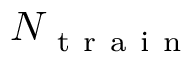<formula> <loc_0><loc_0><loc_500><loc_500>N _ { t r a i n }</formula> 